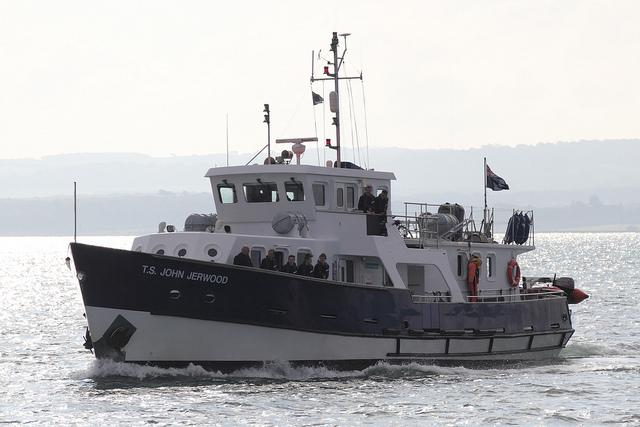Why is there writing on the boat? Please explain your reasoning. boat name. Boats are given a name so they can be different from each other. 